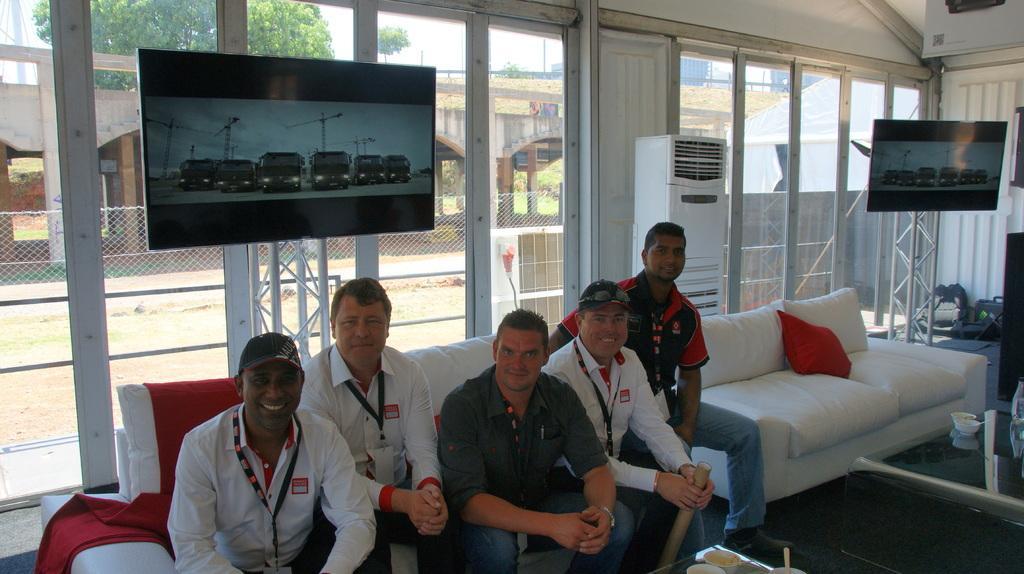Please provide a concise description of this image. In this image I can see number of people are sitting on sofa. In the background I can see few screens and a sofa with cushion on it. 